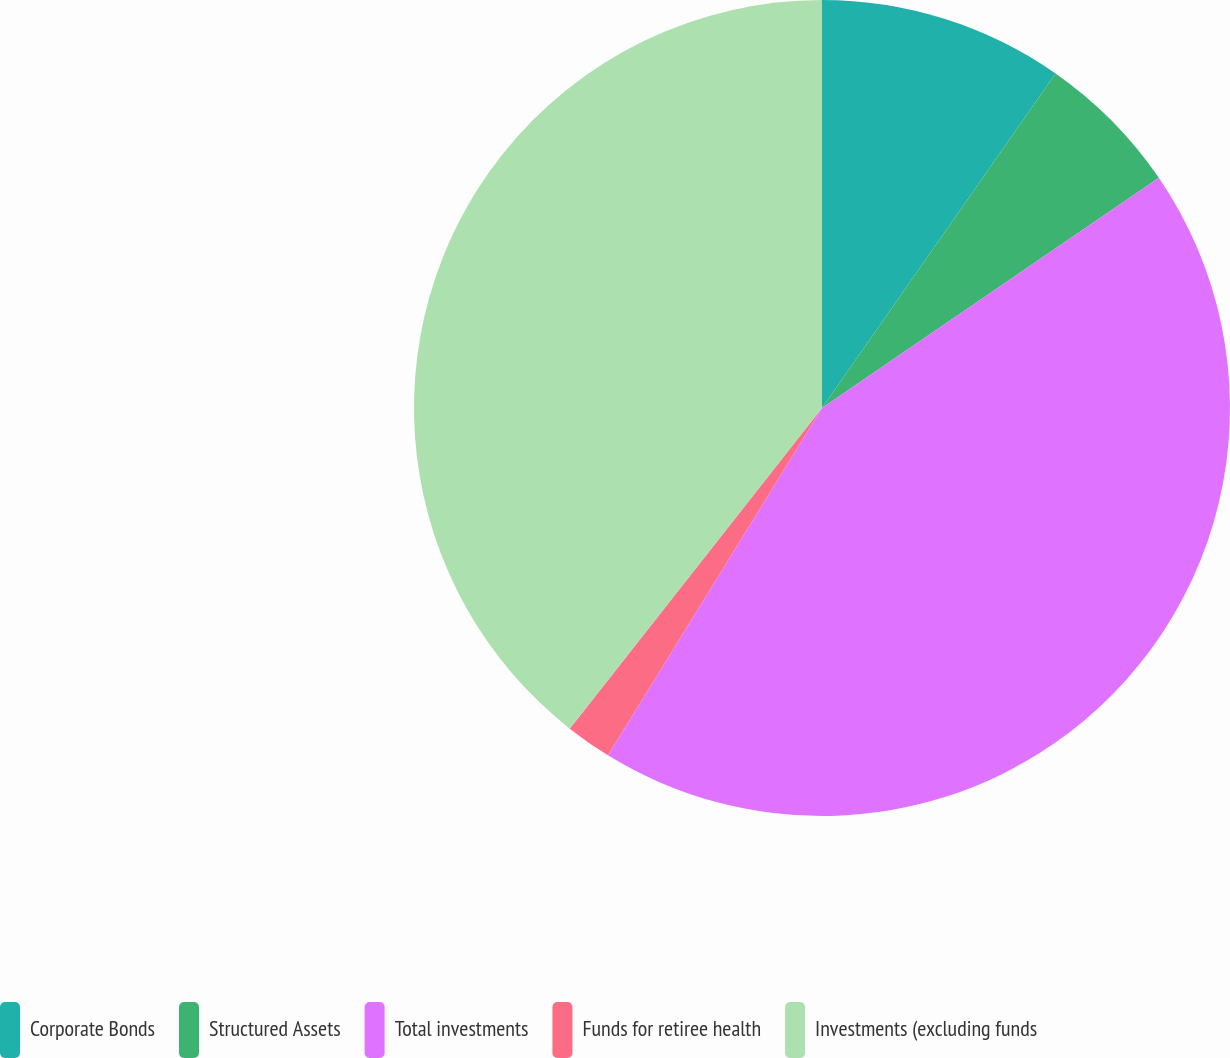<chart> <loc_0><loc_0><loc_500><loc_500><pie_chart><fcel>Corporate Bonds<fcel>Structured Assets<fcel>Total investments<fcel>Funds for retiree health<fcel>Investments (excluding funds<nl><fcel>9.7%<fcel>5.76%<fcel>43.33%<fcel>1.82%<fcel>39.39%<nl></chart> 